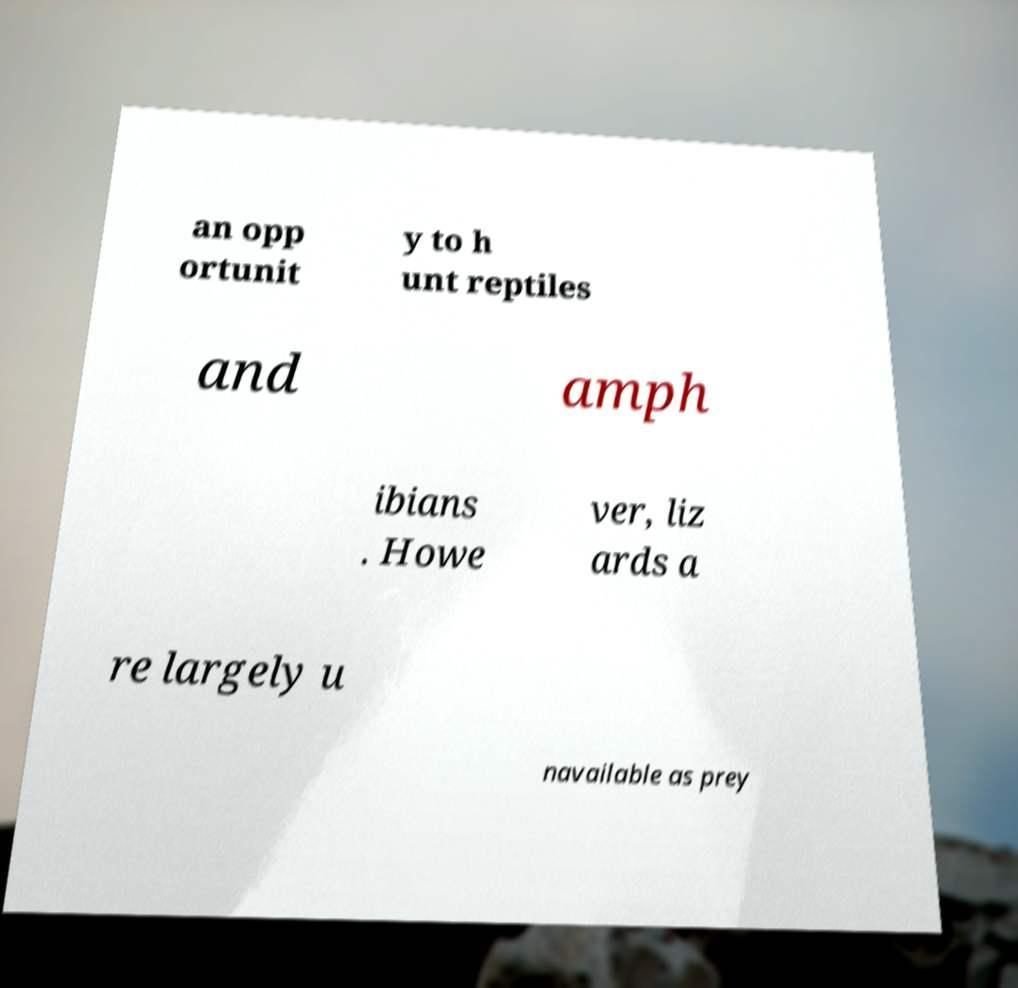What messages or text are displayed in this image? I need them in a readable, typed format. an opp ortunit y to h unt reptiles and amph ibians . Howe ver, liz ards a re largely u navailable as prey 